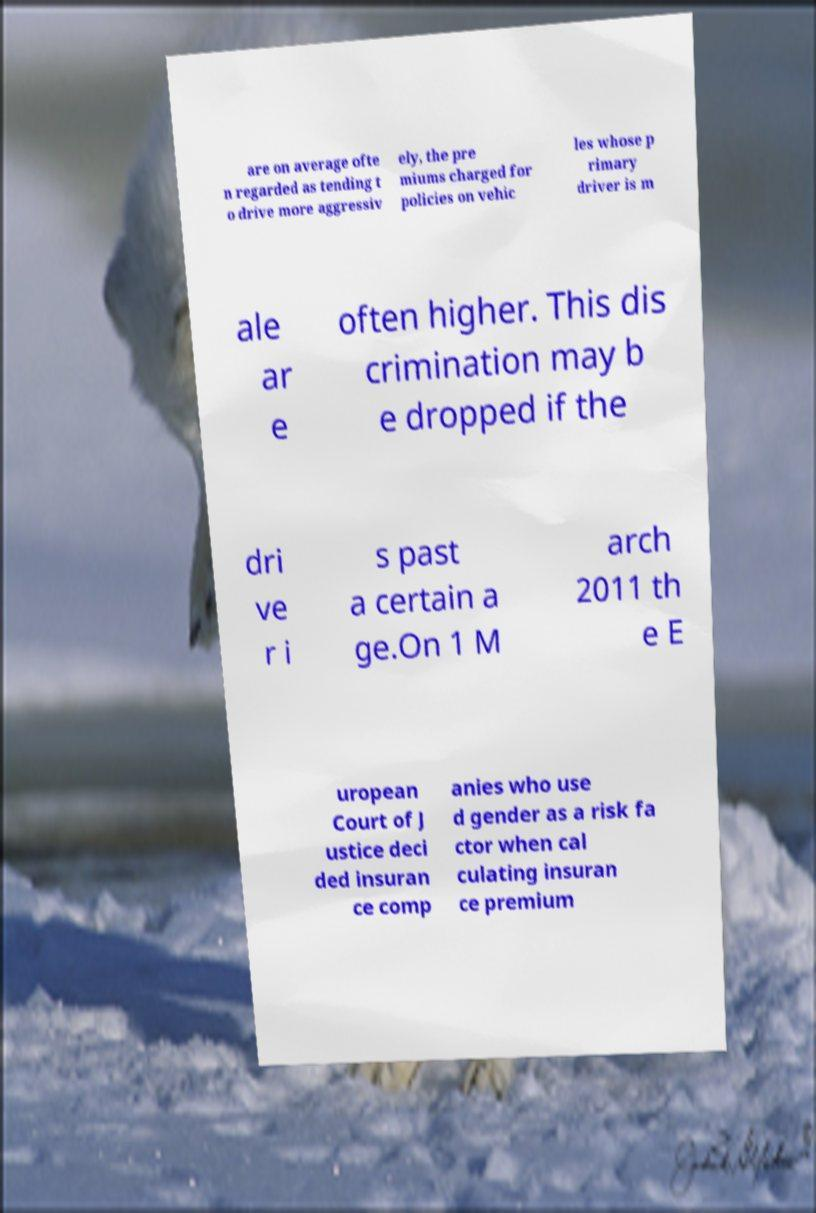Please identify and transcribe the text found in this image. are on average ofte n regarded as tending t o drive more aggressiv ely, the pre miums charged for policies on vehic les whose p rimary driver is m ale ar e often higher. This dis crimination may b e dropped if the dri ve r i s past a certain a ge.On 1 M arch 2011 th e E uropean Court of J ustice deci ded insuran ce comp anies who use d gender as a risk fa ctor when cal culating insuran ce premium 